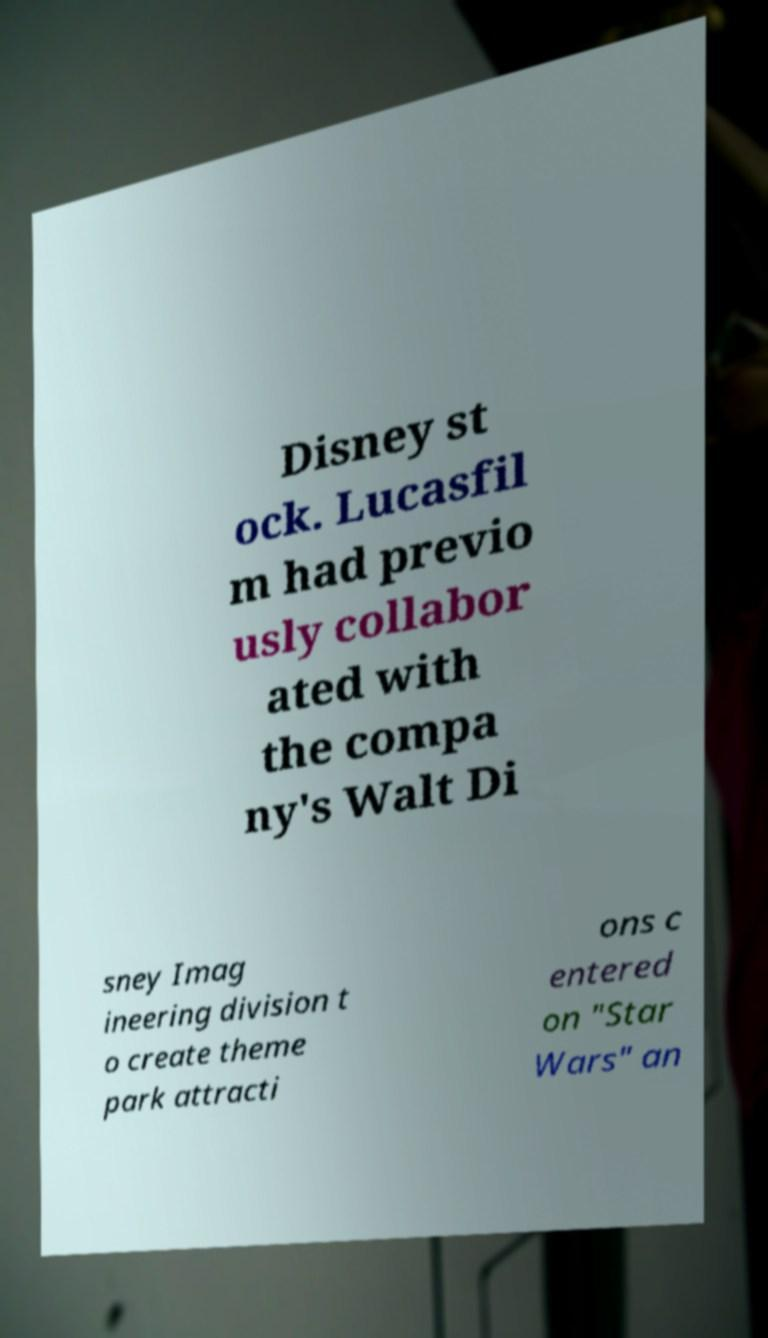Please identify and transcribe the text found in this image. Disney st ock. Lucasfil m had previo usly collabor ated with the compa ny's Walt Di sney Imag ineering division t o create theme park attracti ons c entered on "Star Wars" an 